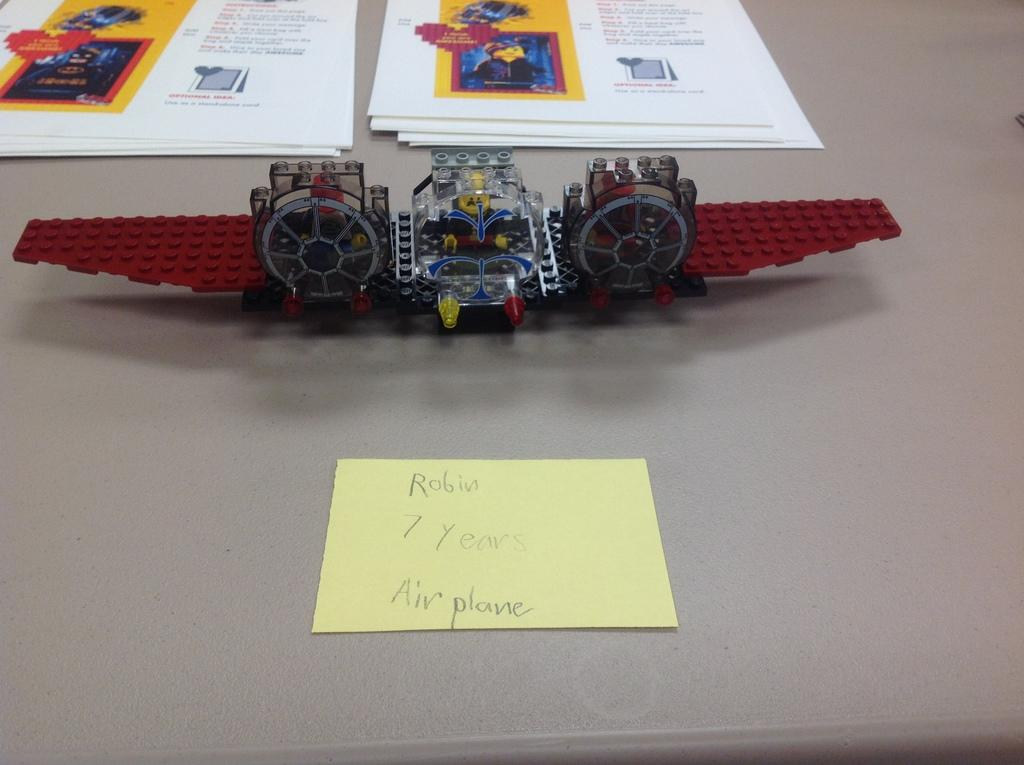What is the main subject in the center of the image? There is an object in the center of the image. What can be seen on the object? The object has a toy on it, and there are papers with text and images on it. What type of underwear is visible on the toy in the image? There is no underwear visible on the toy in the image. What is the taste of the cherries on the papers with text and images? There are no cherries present in the image, so their taste cannot be determined. 